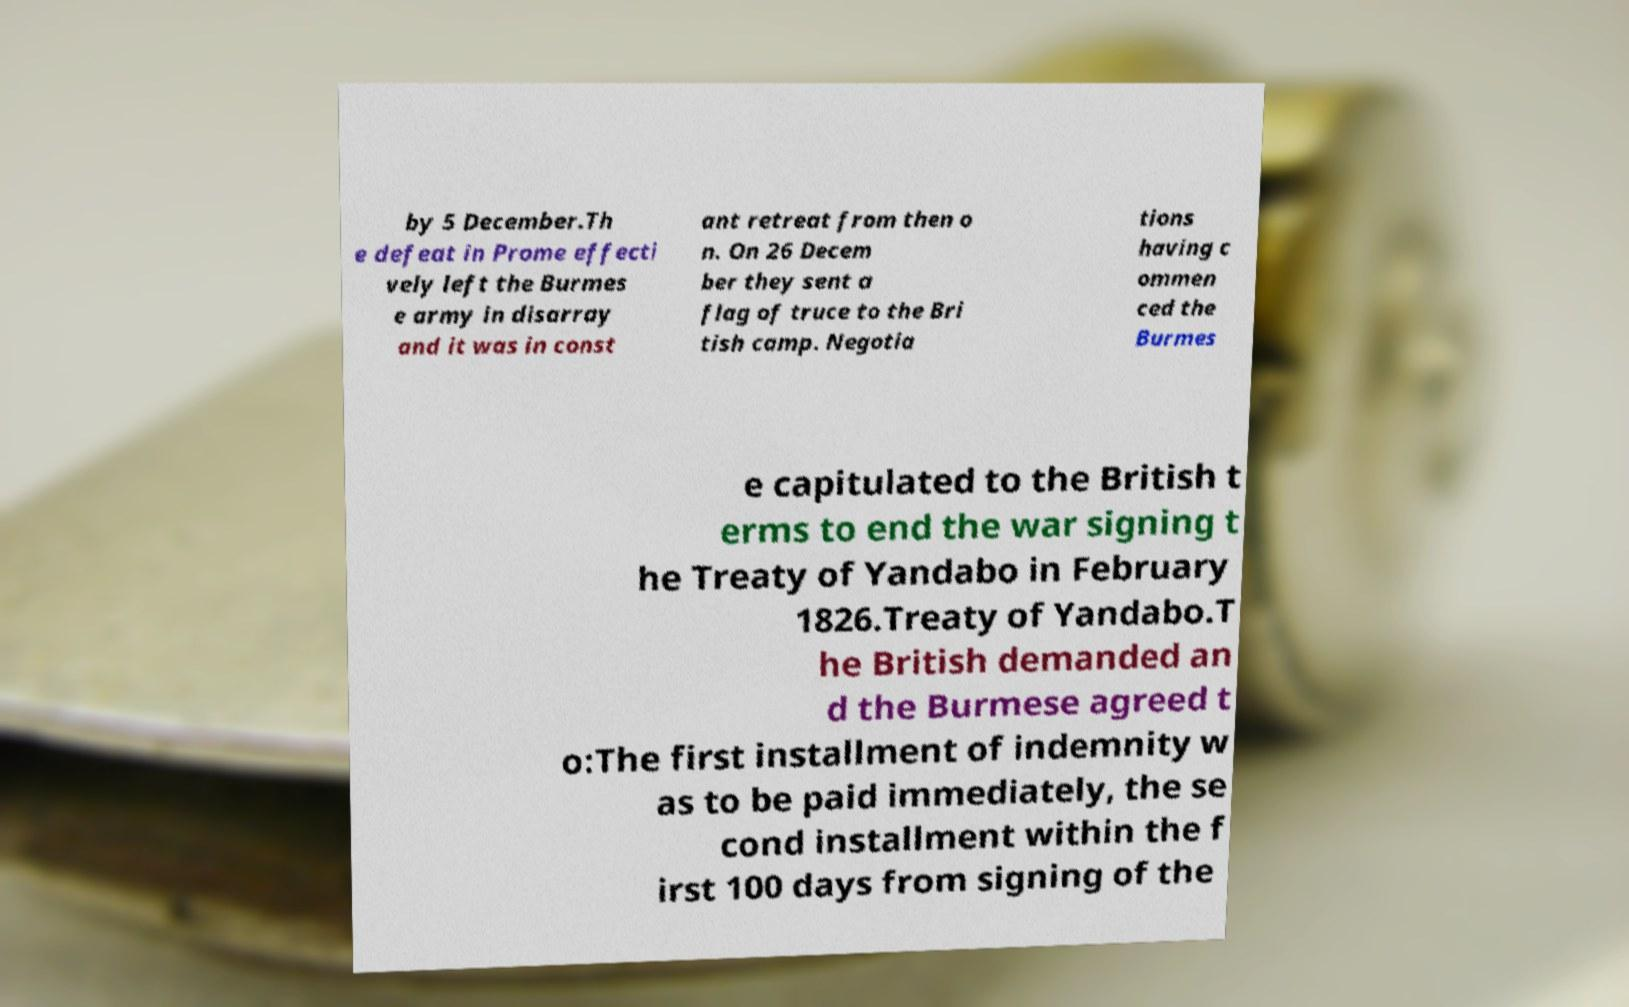Please read and relay the text visible in this image. What does it say? by 5 December.Th e defeat in Prome effecti vely left the Burmes e army in disarray and it was in const ant retreat from then o n. On 26 Decem ber they sent a flag of truce to the Bri tish camp. Negotia tions having c ommen ced the Burmes e capitulated to the British t erms to end the war signing t he Treaty of Yandabo in February 1826.Treaty of Yandabo.T he British demanded an d the Burmese agreed t o:The first installment of indemnity w as to be paid immediately, the se cond installment within the f irst 100 days from signing of the 